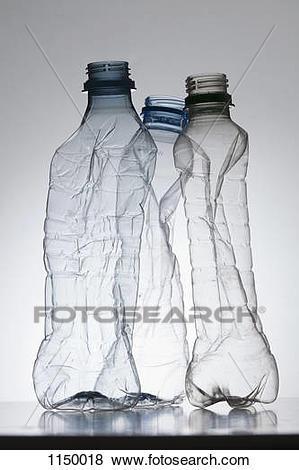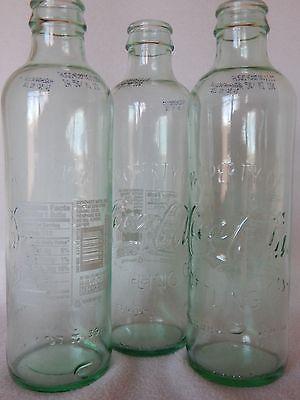The first image is the image on the left, the second image is the image on the right. Assess this claim about the two images: "In one image, three empty bottles with no caps and glistening from a light source, are sitting in a triangle shaped arrangement.". Correct or not? Answer yes or no. Yes. The first image is the image on the left, the second image is the image on the right. Examine the images to the left and right. Is the description "None of the bottles have labels." accurate? Answer yes or no. Yes. 